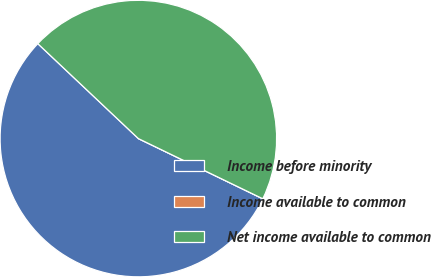<chart> <loc_0><loc_0><loc_500><loc_500><pie_chart><fcel>Income before minority<fcel>Income available to common<fcel>Net income available to common<nl><fcel>54.87%<fcel>0.0%<fcel>45.13%<nl></chart> 